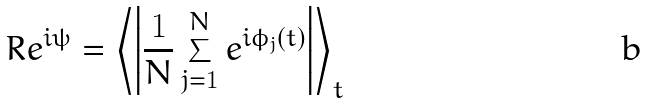Convert formula to latex. <formula><loc_0><loc_0><loc_500><loc_500>R e ^ { i \psi } = \left \langle \left | \frac { 1 } { N } \sum _ { j = 1 } ^ { N } e ^ { i \phi _ { j } ( t ) } \right | \right \rangle _ { t }</formula> 